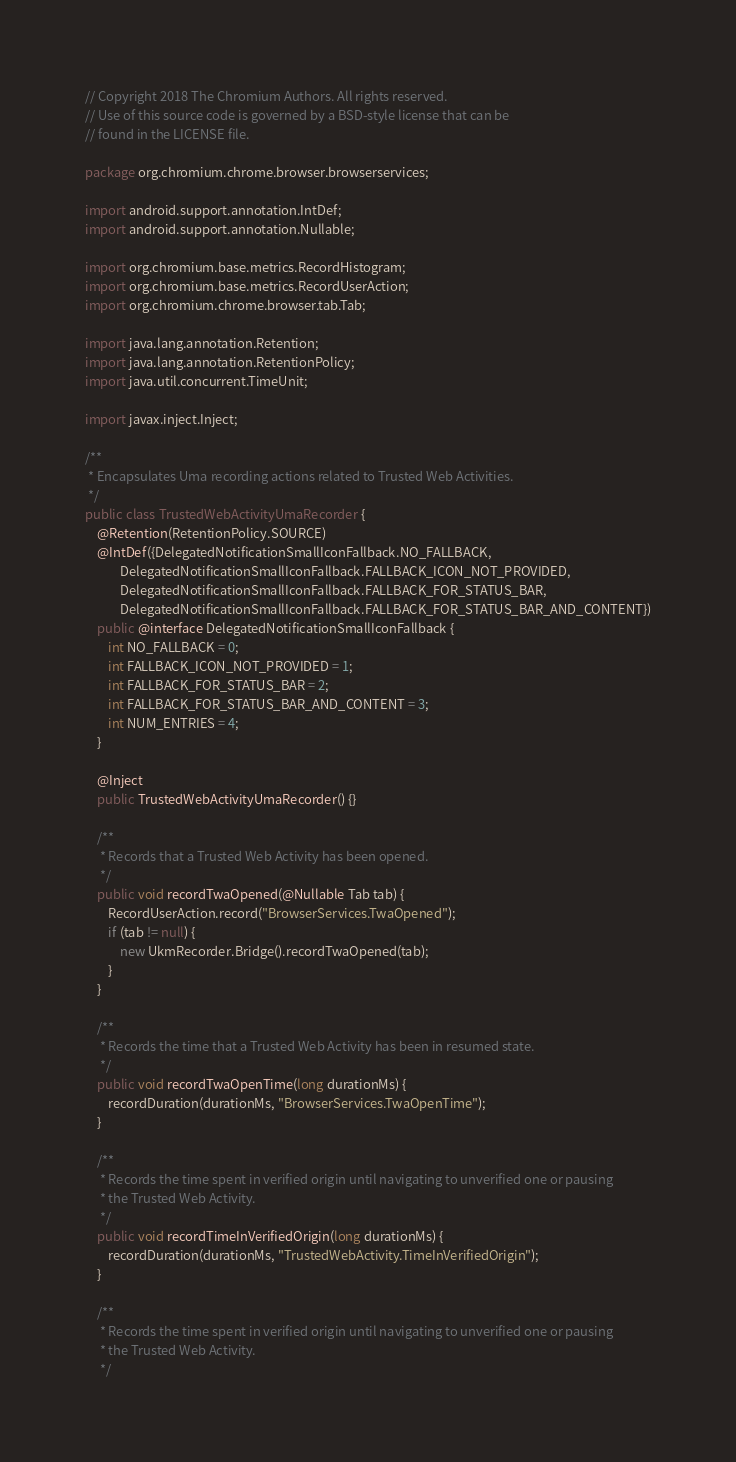Convert code to text. <code><loc_0><loc_0><loc_500><loc_500><_Java_>// Copyright 2018 The Chromium Authors. All rights reserved.
// Use of this source code is governed by a BSD-style license that can be
// found in the LICENSE file.

package org.chromium.chrome.browser.browserservices;

import android.support.annotation.IntDef;
import android.support.annotation.Nullable;

import org.chromium.base.metrics.RecordHistogram;
import org.chromium.base.metrics.RecordUserAction;
import org.chromium.chrome.browser.tab.Tab;

import java.lang.annotation.Retention;
import java.lang.annotation.RetentionPolicy;
import java.util.concurrent.TimeUnit;

import javax.inject.Inject;

/**
 * Encapsulates Uma recording actions related to Trusted Web Activities.
 */
public class TrustedWebActivityUmaRecorder {
    @Retention(RetentionPolicy.SOURCE)
    @IntDef({DelegatedNotificationSmallIconFallback.NO_FALLBACK,
            DelegatedNotificationSmallIconFallback.FALLBACK_ICON_NOT_PROVIDED,
            DelegatedNotificationSmallIconFallback.FALLBACK_FOR_STATUS_BAR,
            DelegatedNotificationSmallIconFallback.FALLBACK_FOR_STATUS_BAR_AND_CONTENT})
    public @interface DelegatedNotificationSmallIconFallback {
        int NO_FALLBACK = 0;
        int FALLBACK_ICON_NOT_PROVIDED = 1;
        int FALLBACK_FOR_STATUS_BAR = 2;
        int FALLBACK_FOR_STATUS_BAR_AND_CONTENT = 3;
        int NUM_ENTRIES = 4;
    }

    @Inject
    public TrustedWebActivityUmaRecorder() {}

    /**
     * Records that a Trusted Web Activity has been opened.
     */
    public void recordTwaOpened(@Nullable Tab tab) {
        RecordUserAction.record("BrowserServices.TwaOpened");
        if (tab != null) {
            new UkmRecorder.Bridge().recordTwaOpened(tab);
        }
    }

    /**
     * Records the time that a Trusted Web Activity has been in resumed state.
     */
    public void recordTwaOpenTime(long durationMs) {
        recordDuration(durationMs, "BrowserServices.TwaOpenTime");
    }

    /**
     * Records the time spent in verified origin until navigating to unverified one or pausing
     * the Trusted Web Activity.
     */
    public void recordTimeInVerifiedOrigin(long durationMs) {
        recordDuration(durationMs, "TrustedWebActivity.TimeInVerifiedOrigin");
    }

    /**
     * Records the time spent in verified origin until navigating to unverified one or pausing
     * the Trusted Web Activity.
     */</code> 